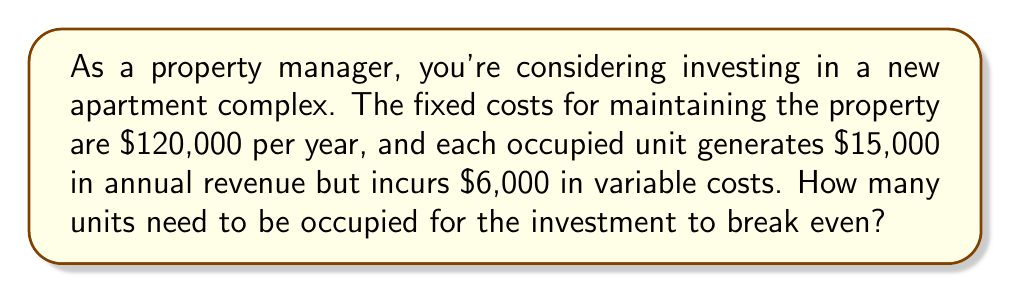What is the answer to this math problem? Let's approach this step-by-step using a linear equation:

1) Define variables:
   Let $x$ = number of occupied units
   Let $y$ = total profit

2) Set up the linear equation:
   Revenue = $15,000x$
   Total Costs = Fixed Costs + Variable Costs
   Total Costs = $120,000 + 6,000x$

3) Profit equation:
   $y = \text{Revenue} - \text{Total Costs}$
   $y = 15,000x - (120,000 + 6,000x)$
   $y = 15,000x - 120,000 - 6,000x$
   $y = 9,000x - 120,000$

4) At break-even point, profit is zero:
   $0 = 9,000x - 120,000$

5) Solve for $x$:
   $120,000 = 9,000x$
   $x = \frac{120,000}{9,000} = \frac{40}{3} = 13.33$

6) Since we can't have a fractional unit, we round up to the nearest whole number.

Therefore, 14 units need to be occupied for the investment to break even.
Answer: 14 units 